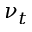Convert formula to latex. <formula><loc_0><loc_0><loc_500><loc_500>\nu _ { t }</formula> 